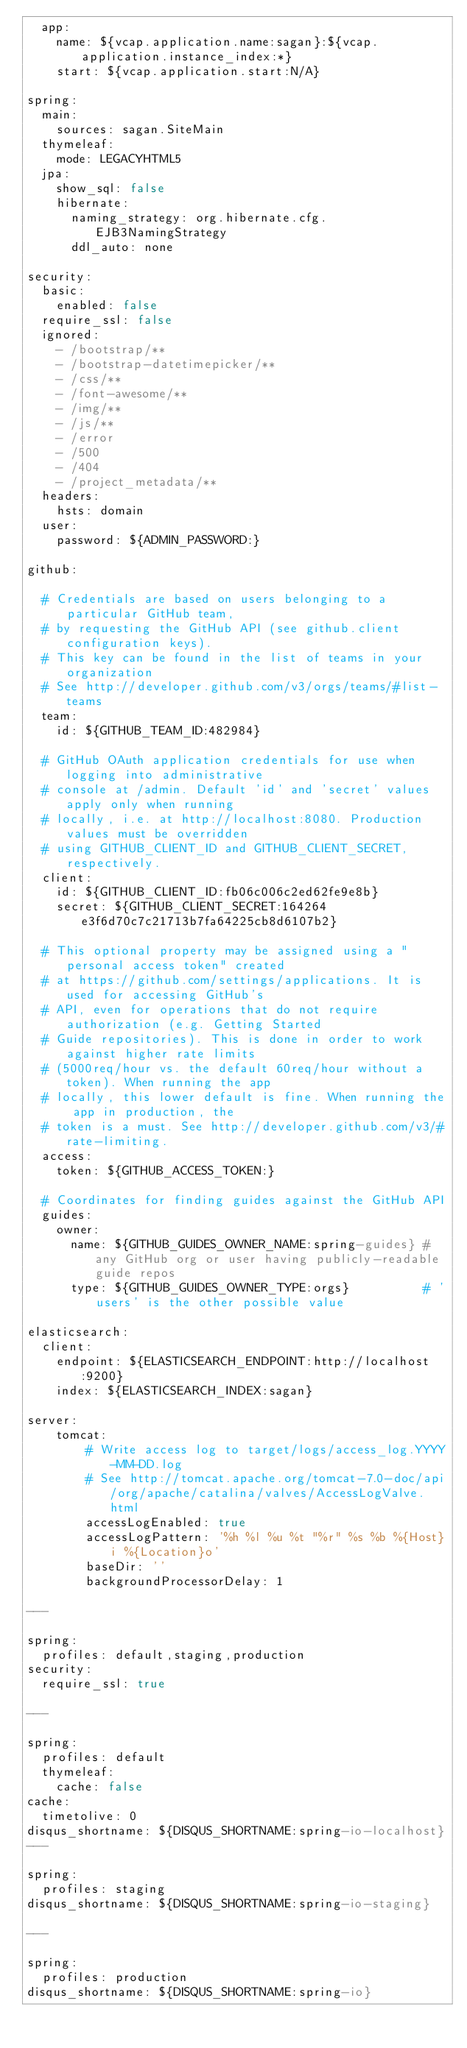Convert code to text. <code><loc_0><loc_0><loc_500><loc_500><_YAML_>  app:
    name: ${vcap.application.name:sagan}:${vcap.application.instance_index:*}
    start: ${vcap.application.start:N/A}

spring:
  main:
    sources: sagan.SiteMain
  thymeleaf:
    mode: LEGACYHTML5
  jpa:
    show_sql: false
    hibernate:
      naming_strategy: org.hibernate.cfg.EJB3NamingStrategy
      ddl_auto: none

security:
  basic:
    enabled: false
  require_ssl: false
  ignored: 
    - /bootstrap/**
    - /bootstrap-datetimepicker/**
    - /css/**
    - /font-awesome/**
    - /img/**
    - /js/**
    - /error
    - /500
    - /404
    - /project_metadata/**
  headers:
    hsts: domain
  user:
    password: ${ADMIN_PASSWORD:}

github:

  # Credentials are based on users belonging to a particular GitHub team,
  # by requesting the GitHub API (see github.client configuration keys).
  # This key can be found in the list of teams in your organization
  # See http://developer.github.com/v3/orgs/teams/#list-teams
  team:
    id: ${GITHUB_TEAM_ID:482984}

  # GitHub OAuth application credentials for use when logging into administrative
  # console at /admin. Default 'id' and 'secret' values apply only when running
  # locally, i.e. at http://localhost:8080. Production values must be overridden
  # using GITHUB_CLIENT_ID and GITHUB_CLIENT_SECRET, respectively.
  client:
    id: ${GITHUB_CLIENT_ID:fb06c006c2ed62fe9e8b}
    secret: ${GITHUB_CLIENT_SECRET:164264e3f6d70c7c21713b7fa64225cb8d6107b2}

  # This optional property may be assigned using a "personal access token" created
  # at https://github.com/settings/applications. It is used for accessing GitHub's
  # API, even for operations that do not require authorization (e.g. Getting Started
  # Guide repositories). This is done in order to work against higher rate limits
  # (5000req/hour vs. the default 60req/hour without a token). When running the app
  # locally, this lower default is fine. When running the app in production, the
  # token is a must. See http://developer.github.com/v3/#rate-limiting.
  access:
    token: ${GITHUB_ACCESS_TOKEN:}

  # Coordinates for finding guides against the GitHub API
  guides:
    owner:
      name: ${GITHUB_GUIDES_OWNER_NAME:spring-guides} # any GitHub org or user having publicly-readable guide repos
      type: ${GITHUB_GUIDES_OWNER_TYPE:orgs}          # 'users' is the other possible value

elasticsearch:
  client:
    endpoint: ${ELASTICSEARCH_ENDPOINT:http://localhost:9200}
    index: ${ELASTICSEARCH_INDEX:sagan}

server:
    tomcat:
        # Write access log to target/logs/access_log.YYYY-MM-DD.log
        # See http://tomcat.apache.org/tomcat-7.0-doc/api/org/apache/catalina/valves/AccessLogValve.html
        accessLogEnabled: true
        accessLogPattern: '%h %l %u %t "%r" %s %b %{Host}i %{Location}o'
        baseDir: ''
        backgroundProcessorDelay: 1

---

spring:
  profiles: default,staging,production
security:
  require_ssl: true

---

spring:
  profiles: default
  thymeleaf:
    cache: false
cache:
  timetolive: 0
disqus_shortname: ${DISQUS_SHORTNAME:spring-io-localhost}
---

spring:
  profiles: staging
disqus_shortname: ${DISQUS_SHORTNAME:spring-io-staging}

---

spring:
  profiles: production
disqus_shortname: ${DISQUS_SHORTNAME:spring-io}</code> 